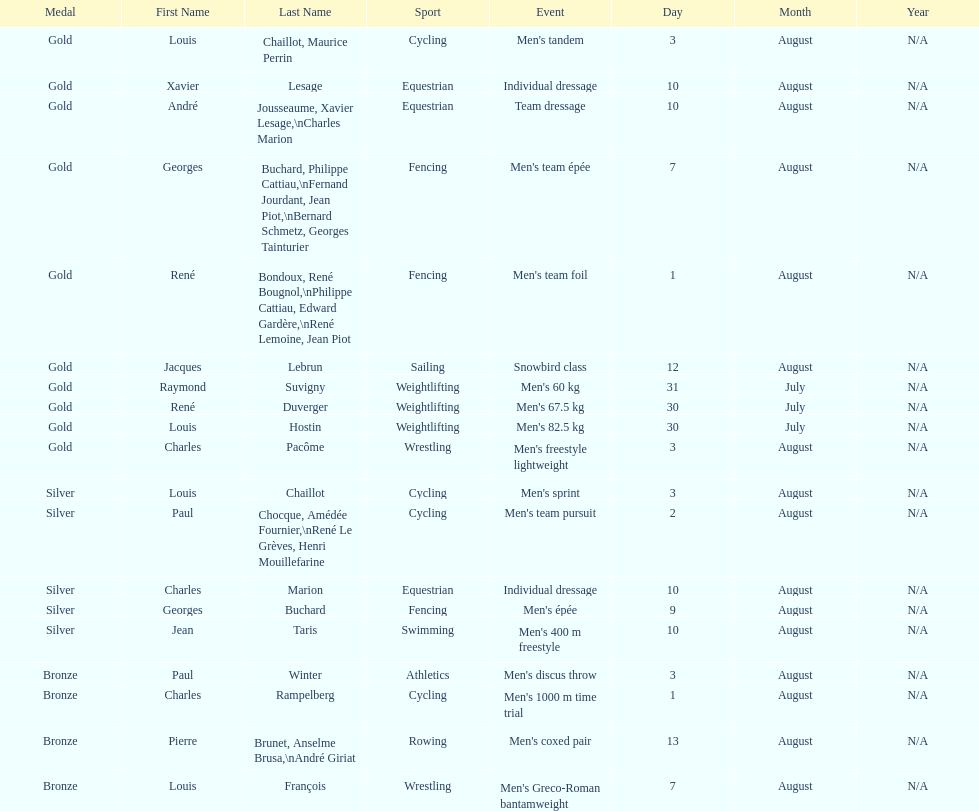How many medals were won after august 3? 9. Help me parse the entirety of this table. {'header': ['Medal', 'First Name', 'Last Name', 'Sport', 'Event', 'Day', 'Month', 'Year'], 'rows': [['Gold', 'Louis', 'Chaillot, Maurice Perrin', 'Cycling', "Men's tandem", '3', 'August', 'N/A'], ['Gold', 'Xavier', 'Lesage', 'Equestrian', 'Individual dressage', '10', 'August', 'N/A'], ['Gold', 'André', 'Jousseaume, Xavier Lesage,\\nCharles Marion', 'Equestrian', 'Team dressage', '10', 'August', 'N/A'], ['Gold', 'Georges', 'Buchard, Philippe Cattiau,\\nFernand Jourdant, Jean Piot,\\nBernard Schmetz, Georges Tainturier', 'Fencing', "Men's team épée", '7', 'August', 'N/A'], ['Gold', 'René', 'Bondoux, René Bougnol,\\nPhilippe Cattiau, Edward Gardère,\\nRené Lemoine, Jean Piot', 'Fencing', "Men's team foil", '1', 'August', 'N/A'], ['Gold', 'Jacques', 'Lebrun', 'Sailing', 'Snowbird class', '12', 'August', 'N/A'], ['Gold', 'Raymond', 'Suvigny', 'Weightlifting', "Men's 60 kg", '31', 'July', 'N/A'], ['Gold', 'René', 'Duverger', 'Weightlifting', "Men's 67.5 kg", '30', 'July', 'N/A'], ['Gold', 'Louis', 'Hostin', 'Weightlifting', "Men's 82.5 kg", '30', 'July', 'N/A'], ['Gold', 'Charles', 'Pacôme', 'Wrestling', "Men's freestyle lightweight", '3', 'August', 'N/A'], ['Silver', 'Louis', 'Chaillot', 'Cycling', "Men's sprint", '3', 'August', 'N/A'], ['Silver', 'Paul', 'Chocque, Amédée Fournier,\\nRené Le Grèves, Henri Mouillefarine', 'Cycling', "Men's team pursuit", '2', 'August', 'N/A'], ['Silver', 'Charles', 'Marion', 'Equestrian', 'Individual dressage', '10', 'August', 'N/A'], ['Silver', 'Georges', 'Buchard', 'Fencing', "Men's épée", '9', 'August', 'N/A'], ['Silver', 'Jean', 'Taris', 'Swimming', "Men's 400 m freestyle", '10', 'August', 'N/A'], ['Bronze', 'Paul', 'Winter', 'Athletics', "Men's discus throw", '3', 'August', 'N/A'], ['Bronze', 'Charles', 'Rampelberg', 'Cycling', "Men's 1000 m time trial", '1', 'August', 'N/A'], ['Bronze', 'Pierre', 'Brunet, Anselme Brusa,\\nAndré Giriat', 'Rowing', "Men's coxed pair", '13', 'August', 'N/A'], ['Bronze', 'Louis', 'François', 'Wrestling', "Men's Greco-Roman bantamweight", '7', 'August', 'N/A']]} 